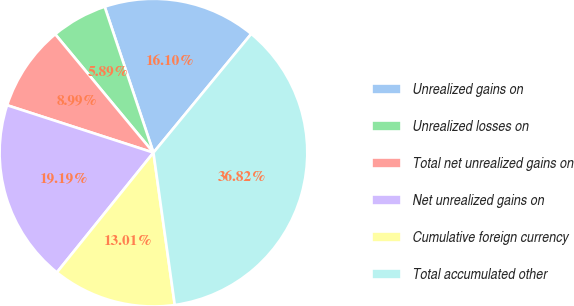<chart> <loc_0><loc_0><loc_500><loc_500><pie_chart><fcel>Unrealized gains on<fcel>Unrealized losses on<fcel>Total net unrealized gains on<fcel>Net unrealized gains on<fcel>Cumulative foreign currency<fcel>Total accumulated other<nl><fcel>16.1%<fcel>5.89%<fcel>8.99%<fcel>19.19%<fcel>13.01%<fcel>36.82%<nl></chart> 